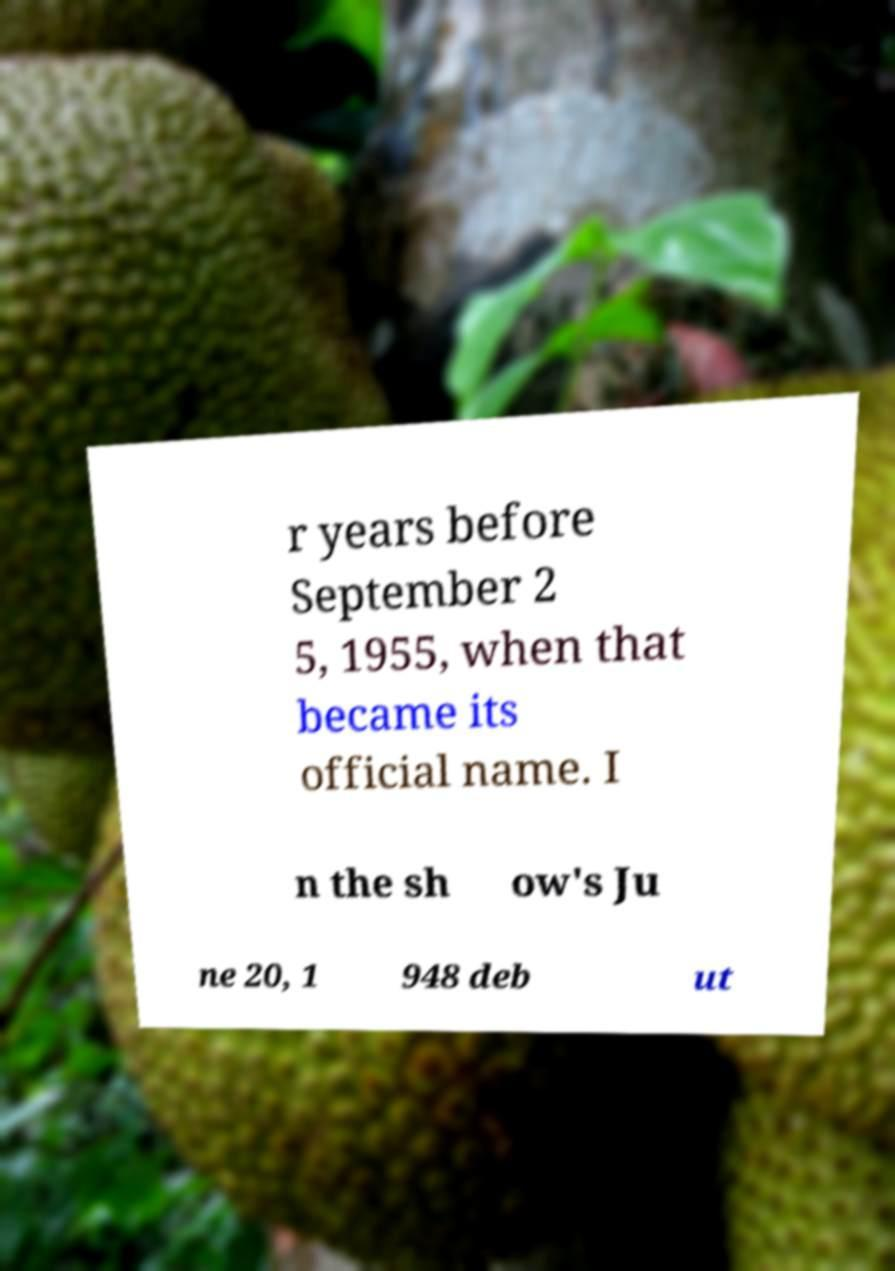Please read and relay the text visible in this image. What does it say? r years before September 2 5, 1955, when that became its official name. I n the sh ow's Ju ne 20, 1 948 deb ut 